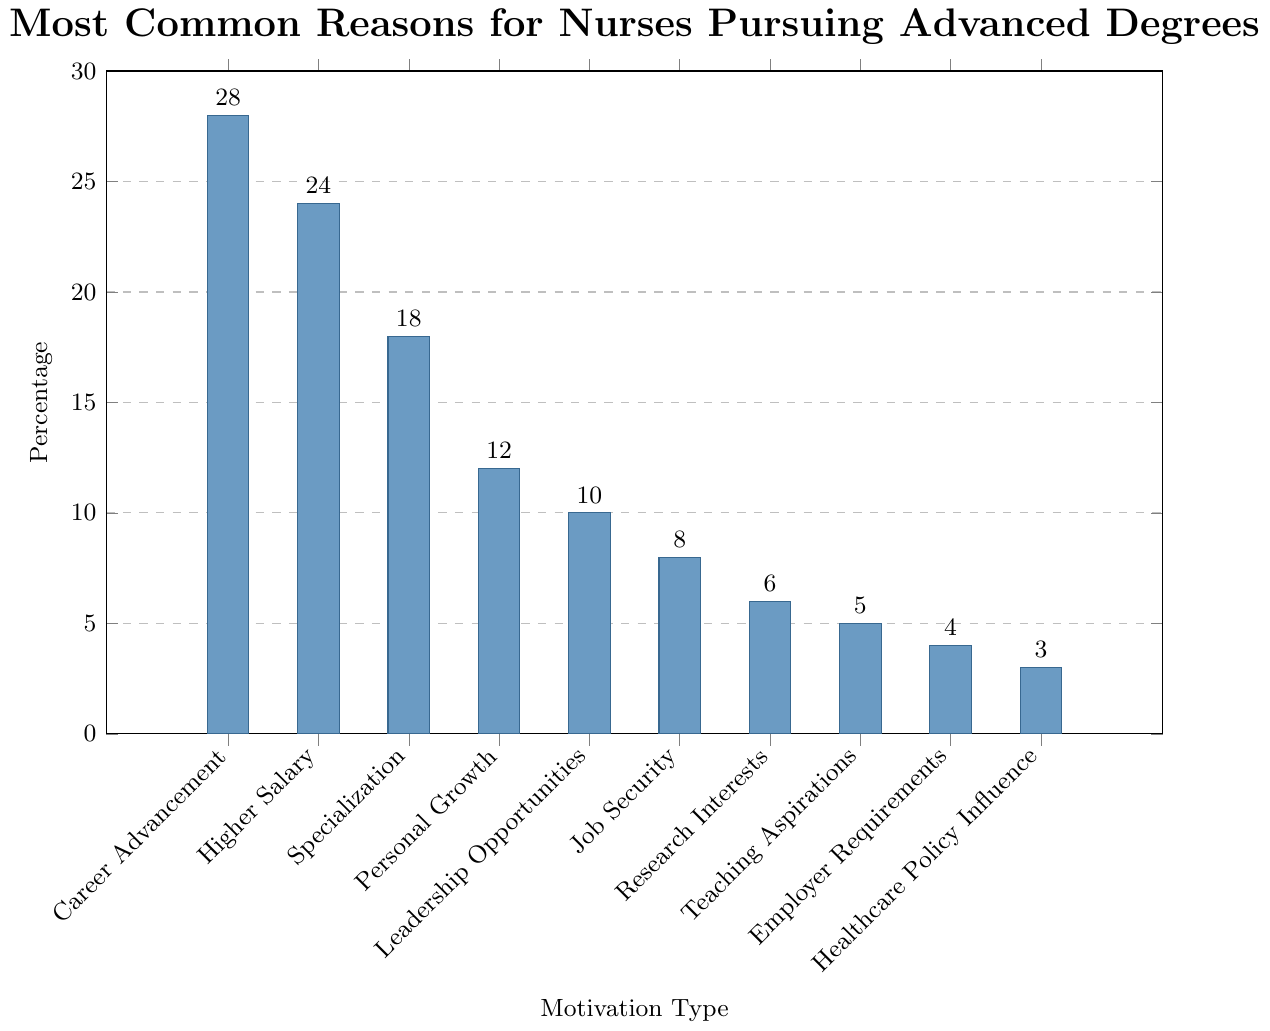What is the most common reason for nurses pursuing advanced degrees? The bar representing "Career Advancement" is the tallest in the chart.
Answer: Career Advancement Which motivation type has the smallest percentage of nurses pursuing advanced degrees? The bar for "Healthcare Policy Influence" is the shortest in the chart.
Answer: Healthcare Policy Influence How much higher is the percentage for "Career Advancement" compared to "Job Security"? The percentage for Career Advancement is 28% and for Job Security, it's 8%. So, 28 - 8 = 20.
Answer: 20% What are the combined percentages for "Higher Salary" and "Specialization"? The percentage for Higher Salary is 24% and for Specialization, it's 18%. So, 24 + 18 = 42.
Answer: 42% What is the approximate difference in height between the bar for "Leadership Opportunities" and "Personal Growth"? The percentage for Personal Growth is 12% and for Leadership Opportunities, it's 10%. So, 12 - 10 = 2.
Answer: 2% Do "Teaching Aspirations" have a higher or lower percentage than "Research Interests"? The percentage for Research Interests is 6% and for Teaching Aspirations, it's 5%. 6 is greater than 5.
Answer: Higher Which motivation types have percentages within 2% of each other? "Job Security" has 8% and "Research Interests" has 6%, differing by 2%. "Leadership Opportunities" has 10% and "Personal Growth" has 12%, also differing by 2%.
Answer: Job Security and Research Interests; Leadership Opportunities and Personal Growth What is the combined percentage for the three least common reasons? The least common reasons are "Healthcare Policy Influence" (3%), "Employer Requirements" (4%), and "Teaching Aspirations" (5%). So, 3 + 4 + 5 = 12.
Answer: 12% Which reason has a lower percentage, "Employer Requirements" or "Leadership Opportunities"? The percentage for Employer Requirements is 4% and for Leadership Opportunities, it's 10%. 4 is less than 10.
Answer: Employer Requirements Among "Personal Growth", "Specialization", and "Research Interests", which has the median value? The percentages are Personal Growth (12%), Specialization (18%), and Research Interests (6%). The median value is the second number when ordered from least to greatest: 6, 12, 18.
Answer: Personal Growth 